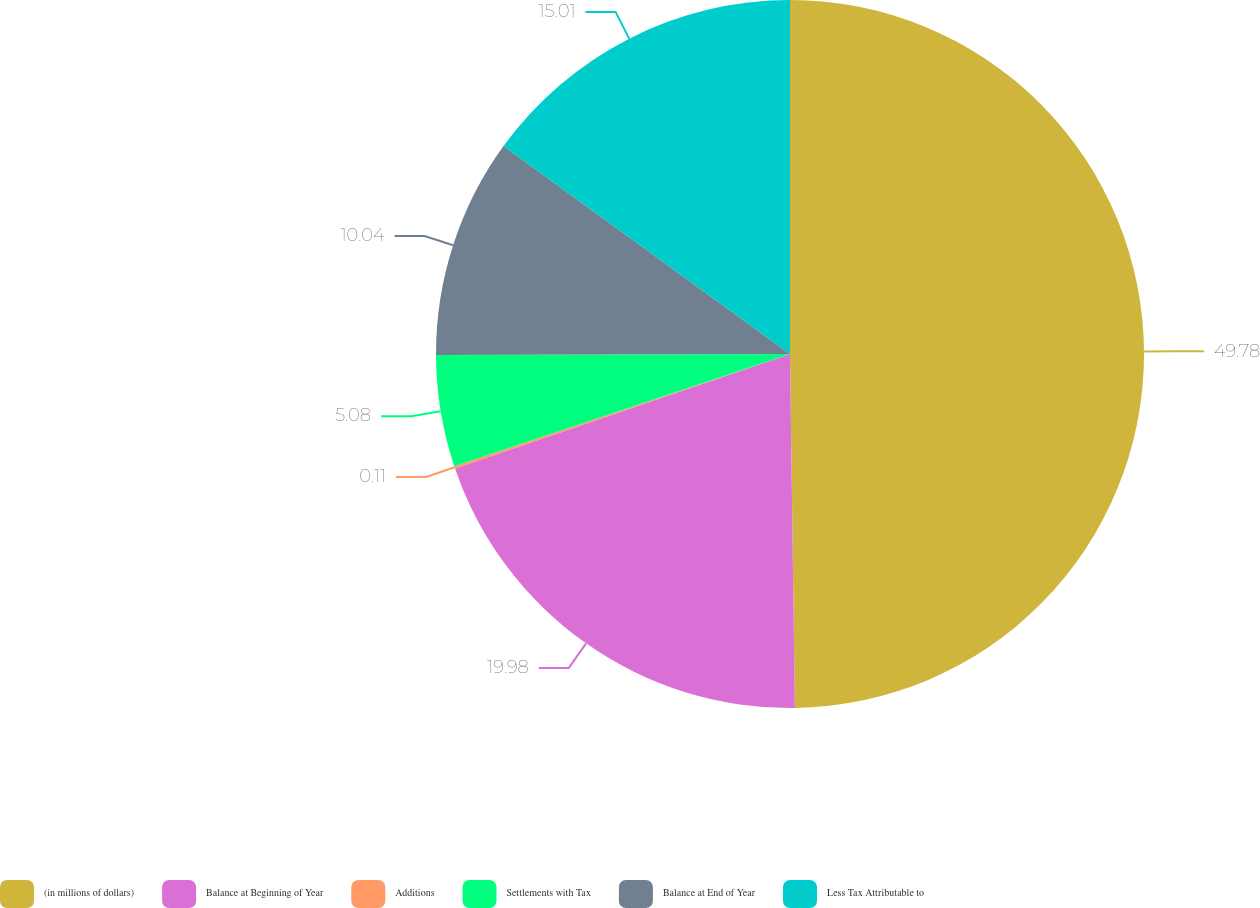<chart> <loc_0><loc_0><loc_500><loc_500><pie_chart><fcel>(in millions of dollars)<fcel>Balance at Beginning of Year<fcel>Additions<fcel>Settlements with Tax<fcel>Balance at End of Year<fcel>Less Tax Attributable to<nl><fcel>49.78%<fcel>19.98%<fcel>0.11%<fcel>5.08%<fcel>10.04%<fcel>15.01%<nl></chart> 